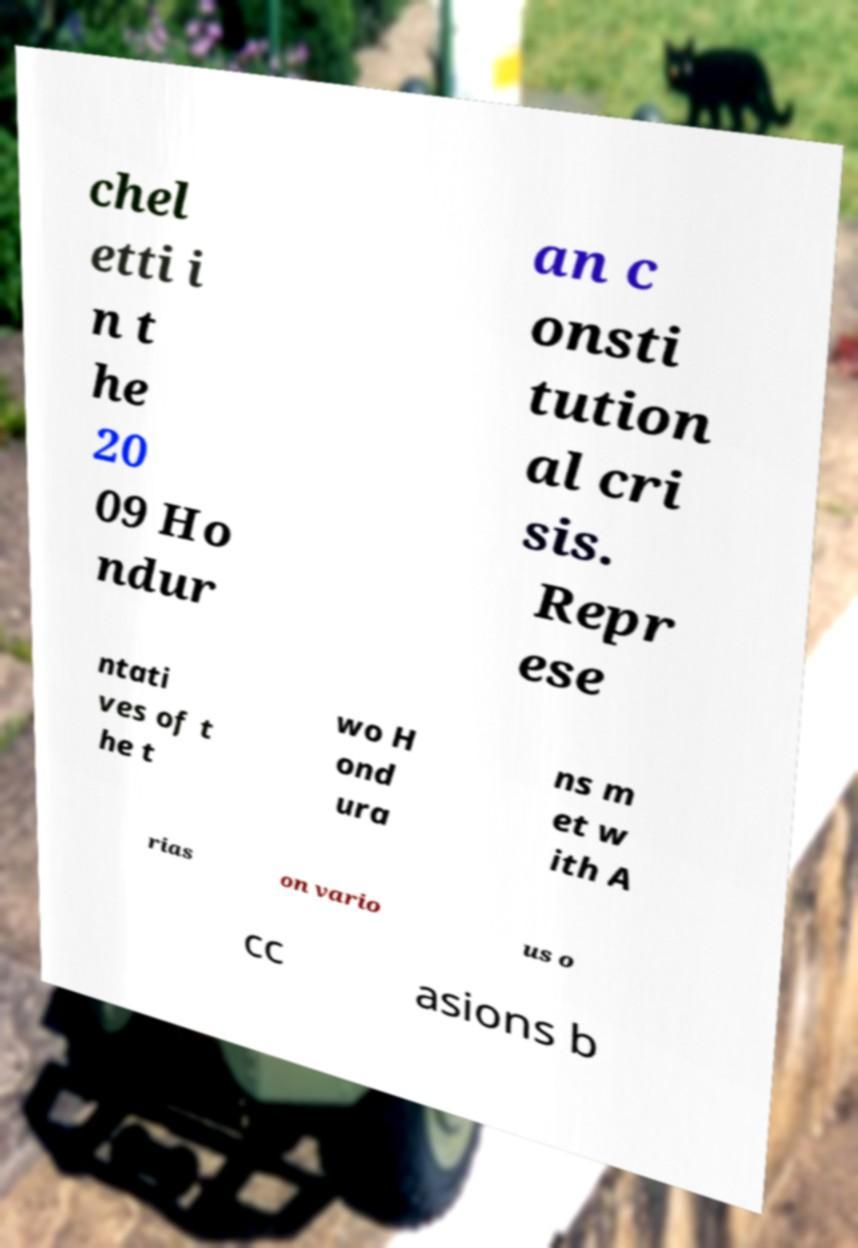There's text embedded in this image that I need extracted. Can you transcribe it verbatim? chel etti i n t he 20 09 Ho ndur an c onsti tution al cri sis. Repr ese ntati ves of t he t wo H ond ura ns m et w ith A rias on vario us o cc asions b 